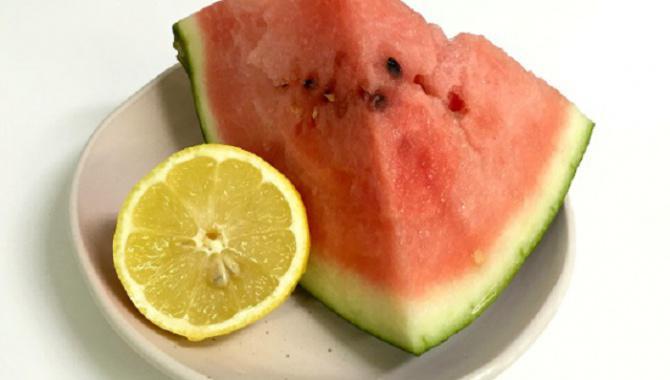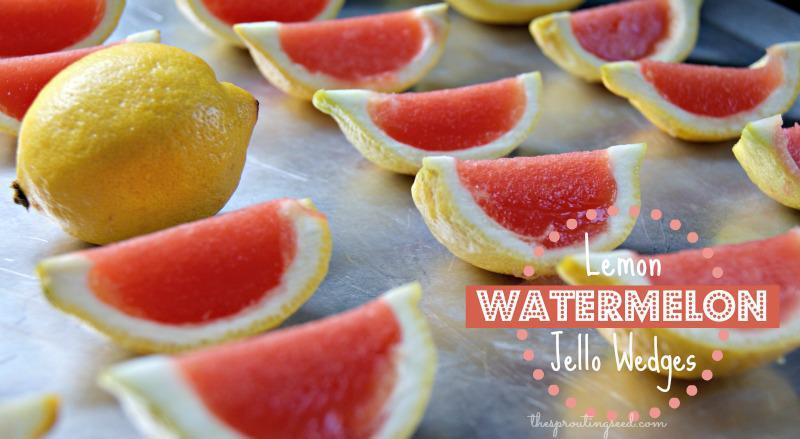The first image is the image on the left, the second image is the image on the right. Evaluate the accuracy of this statement regarding the images: "At least one image features more than one whole lemon.". Is it true? Answer yes or no. No. 